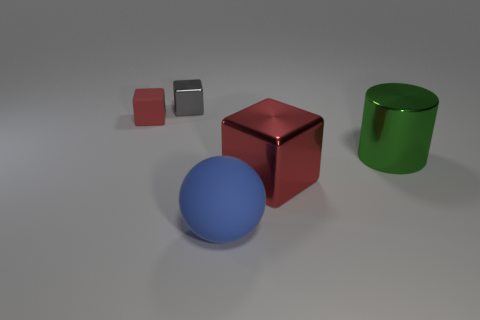What number of objects are tiny red rubber things or metal cubes?
Offer a very short reply. 3. The big blue object is what shape?
Provide a short and direct response. Sphere. There is a red matte object that is the same shape as the small gray metal object; what size is it?
Keep it short and to the point. Small. Is there anything else that has the same material as the gray thing?
Offer a very short reply. Yes. There is a cube that is right of the object that is behind the small matte block; what size is it?
Your response must be concise. Large. Are there the same number of big metallic cubes right of the big metallic cylinder and large metal cylinders?
Your answer should be compact. No. How many other things are there of the same color as the large matte ball?
Your answer should be compact. 0. Are there fewer objects in front of the large blue matte thing than tiny blue metal spheres?
Ensure brevity in your answer.  No. Are there any gray shiny things of the same size as the blue thing?
Provide a succinct answer. No. Does the large ball have the same color as the block in front of the green metal cylinder?
Keep it short and to the point. No. 